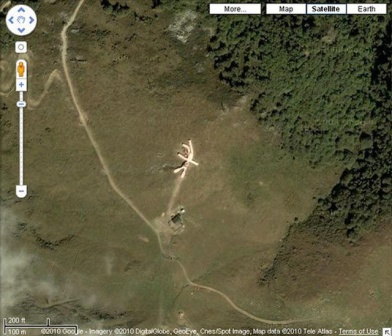Describe a scenario in which this area is used for a high-stakes operation. In the midst of an urgent humanitarian crisis, a high-stakes rescue operation is set in motion. The X-shaped structure serves as the designated landing zone for helicopters carrying rescue teams and supplies. The forest around the clearing is dense and difficult to navigate by ground, making aerial access the only viable option. The smaller structure close by operates as the command center, equipped with communication devices and coordination maps. Rescue personnel, medics, and volunteers work tirelessly to evacuate individuals from the surrounding wilderness, providing essential medical care and relief supplies. As dusk approaches, the urgency heightens, with the area bustling with activity, spotlights illuminating the site, and helicopters making rapid, synchronized landings and take-offs - every second crucial in saving lives.  What if the X-shaped structure is part of an abandoned military base? If this X-shaped structure is part of an abandoned military base, it represents the traces of a once-strategic outpost forgotten by time. The clearing, now overgrown and partially reclaimed by the surrounding forest, whispers echoes of intense training exercises, covert missions, and strategic planning that occurred there decades ago. The metallic structures, now weathered and rusting, hint at technological remnants and possibly classified materials left behind. Exploring the base uncovers barracks, crumbling command centers, and hidden storage facilities. Perhaps a team of historians or treasure hunters discovers it, unearthing stories of valor, top-secret experiments, or lost military artifacts long since buried in the annals of history.  Imagine an alien spaceship lands here. What happens next? The tranquil surroundings of the clearing are shattered as a bright light pierces the sky, followed by the sudden descent of an alien spaceship, gracefully touching down on the X-shaped structure. The craft, sleek and ethereal, emits an otherworldly glow, and a palpable sense of anticipation fills the air. As a hatch slowly opens, a delegation of extraterrestrial beings steps onto the ground, their forms both awe-inspiring and intimidating. Scientists, government officials, and curious locals, alerted by the unearthly event, converge on the scene. Amid hushed whispers and frantic communication, a historic exchange begins, bridging the gap between worlds. The aliens communicate through advanced holographic technology, sharing knowledge unseen by human eyes. This landing site, once a mundane point on a map, transforms into the epicenter of an unprecedented, interstellar diplomatic mission, forever altering the course of human history. 